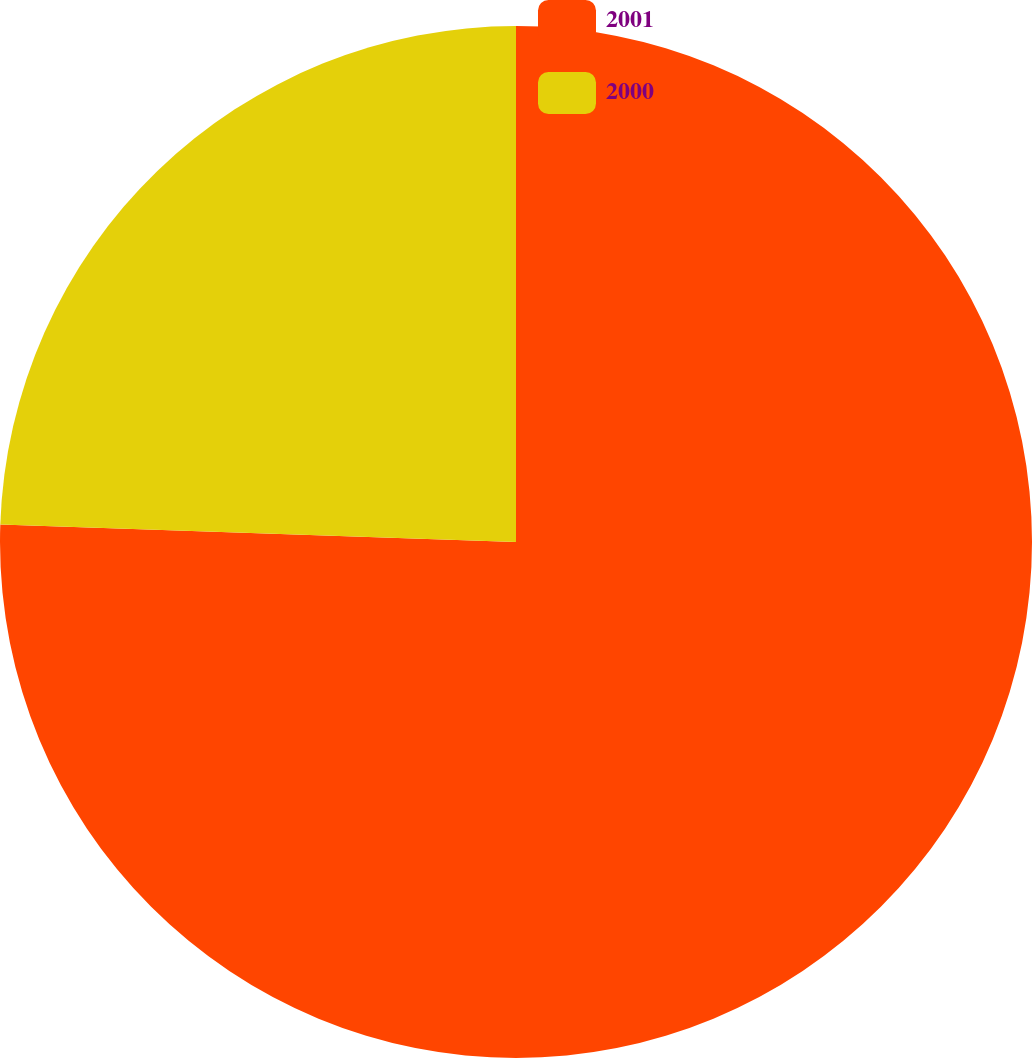Convert chart to OTSL. <chart><loc_0><loc_0><loc_500><loc_500><pie_chart><fcel>2001<fcel>2000<nl><fcel>75.54%<fcel>24.46%<nl></chart> 